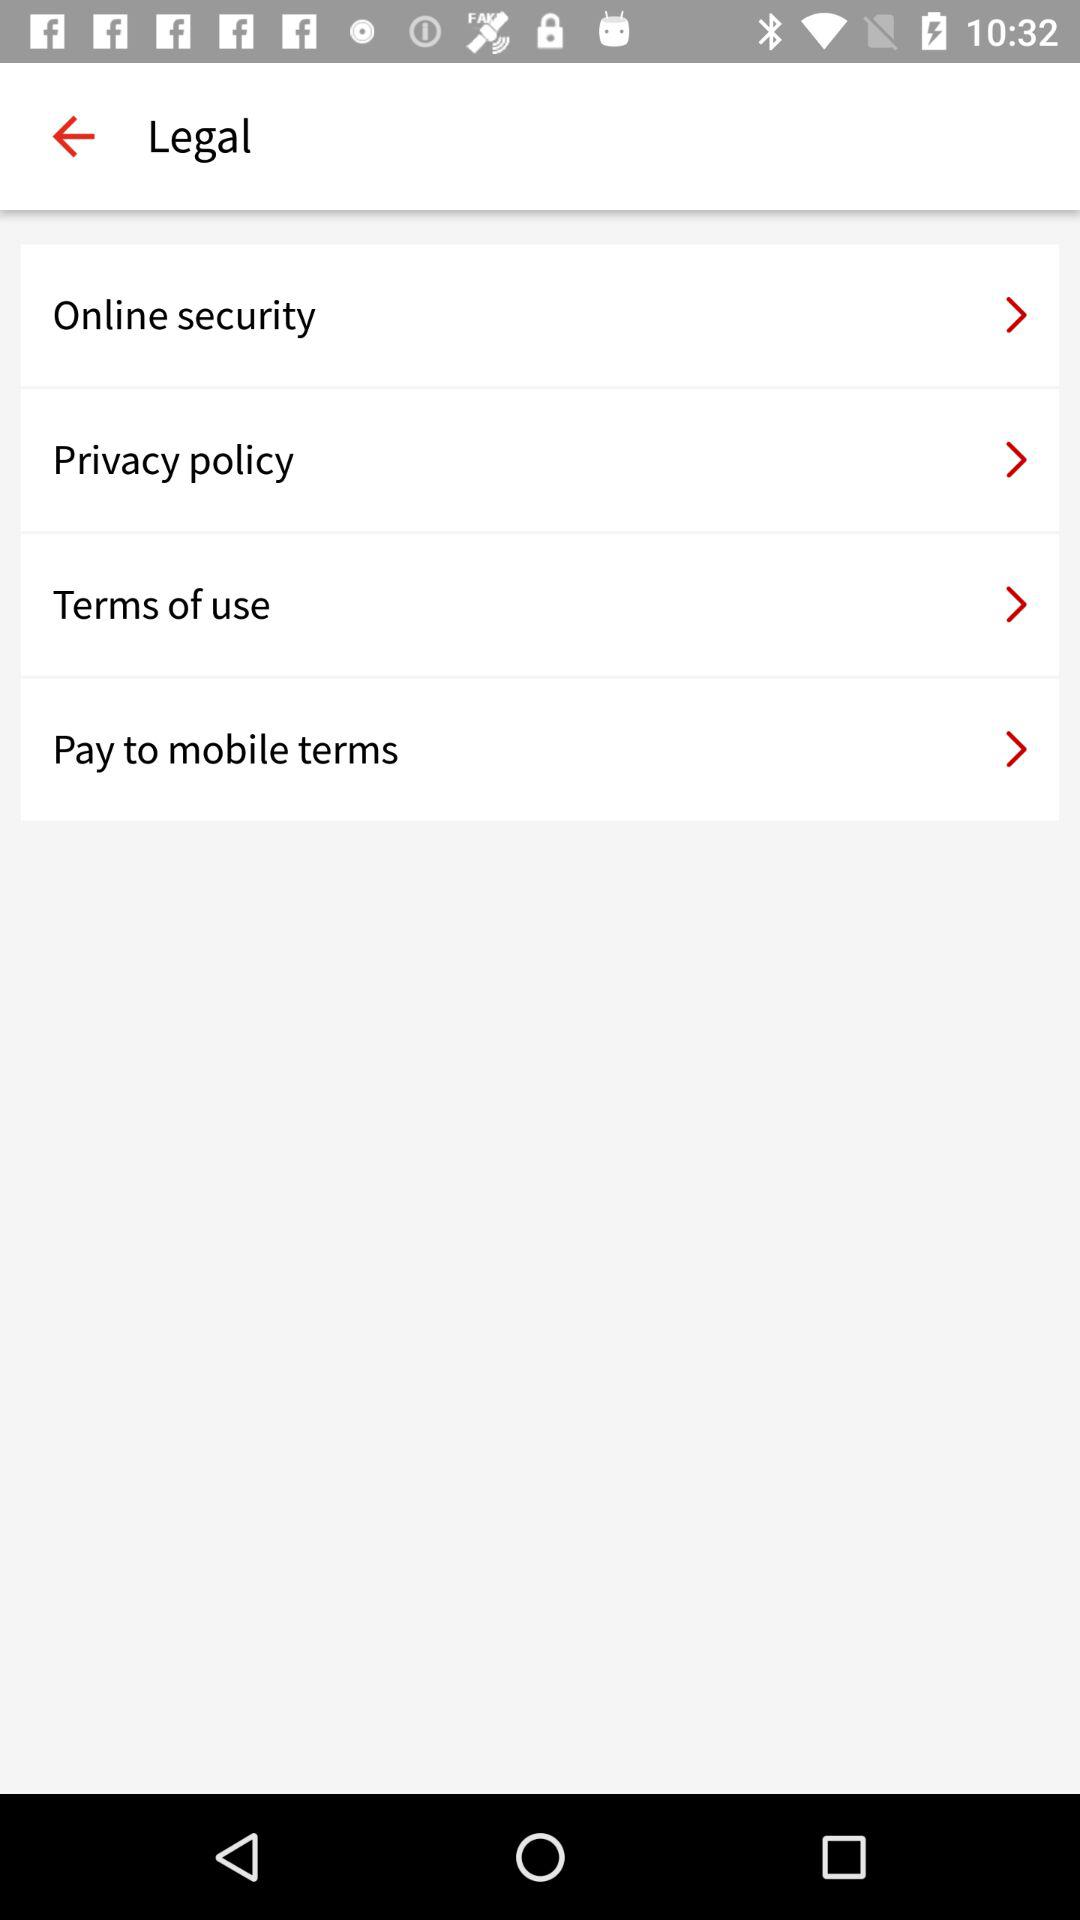How many terms of service do I need to agree to?
Answer the question using a single word or phrase. 4 